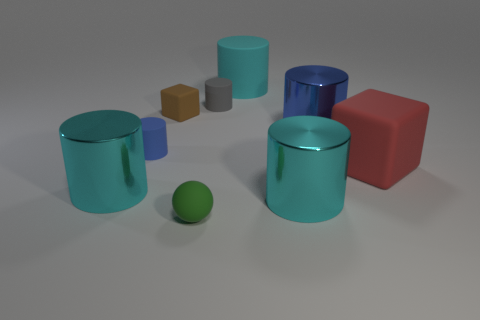How many cyan cylinders must be subtracted to get 1 cyan cylinders? 2 Subtract all brown blocks. How many cyan cylinders are left? 3 Subtract 2 cylinders. How many cylinders are left? 4 Subtract all gray cylinders. How many cylinders are left? 5 Subtract all big blue cylinders. How many cylinders are left? 5 Subtract all brown cylinders. Subtract all brown cubes. How many cylinders are left? 6 Add 1 blue shiny objects. How many objects exist? 10 Subtract all cubes. How many objects are left? 7 Add 1 tiny green matte things. How many tiny green matte things exist? 2 Subtract 1 gray cylinders. How many objects are left? 8 